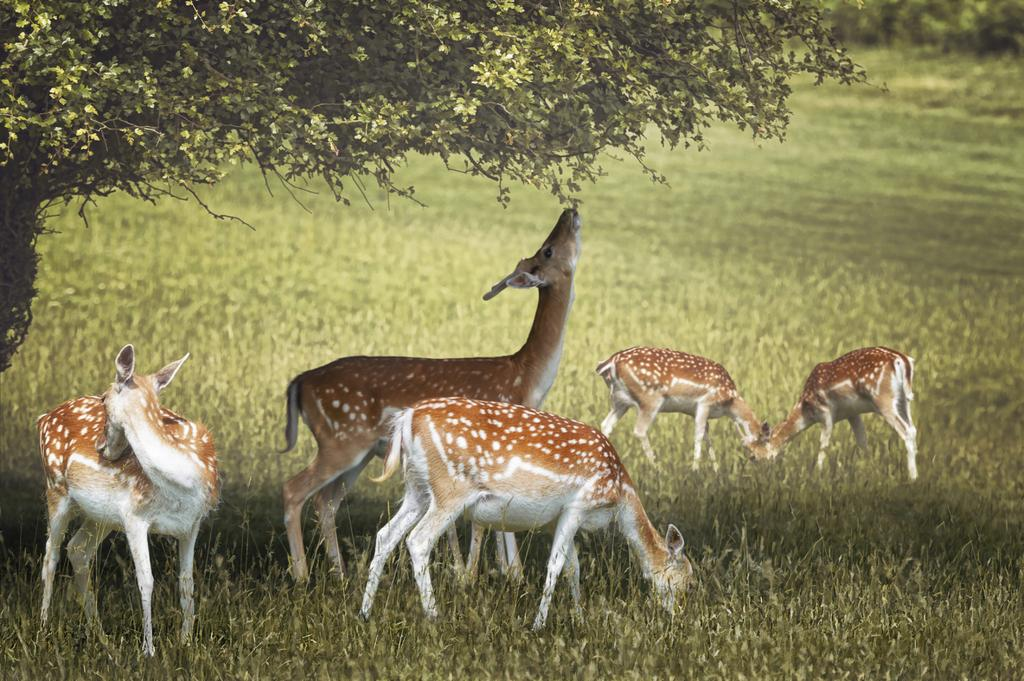What type of vegetation covers the land in the image? The land in the image is covered with grass. What type of animals can be seen in the image? There are deer visible in the image. Can you describe any other natural elements in the image? There is a tree in the image. What type of joke is the deer telling in the image? There is no indication in the image that the deer is telling a joke, as animals do not have the ability to tell jokes. 